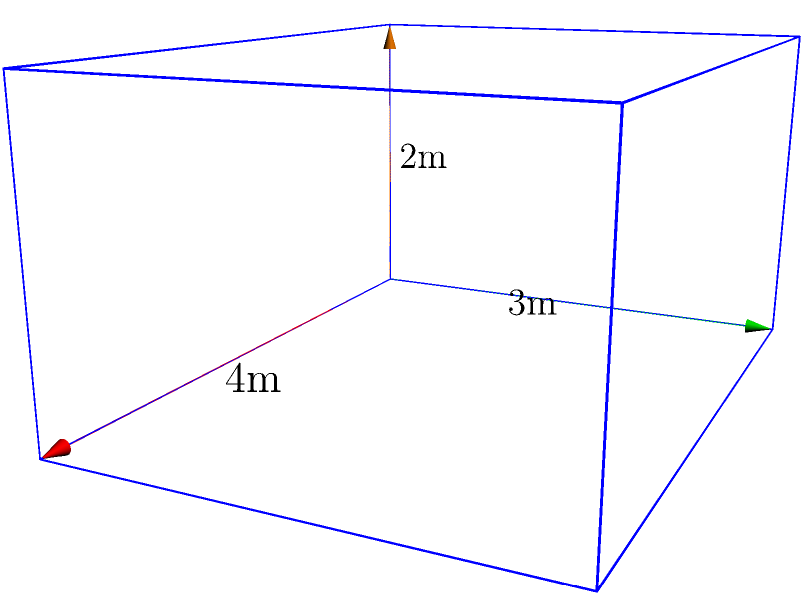A temporary health clinic structure for a tribal community outreach program is designed in the shape of a cuboid. The structure's dimensions are 4 meters in length, 3 meters in width, and 2 meters in height. If the clinic needs to maintain a minimum air volume of 20 cubic meters for proper ventilation, does this structure meet the requirement? If not, by how many cubic meters does it fall short? To solve this problem, we need to follow these steps:

1. Calculate the volume of the cuboid-shaped clinic:
   Volume = length × width × height
   $$V = 4 \text{ m} \times 3 \text{ m} \times 2 \text{ m} = 24 \text{ m}^3$$

2. Compare the calculated volume with the required minimum volume:
   Required minimum volume = 20 m³
   Calculated volume = 24 m³

3. Determine if the requirement is met:
   24 m³ > 20 m³, so the requirement is met.

4. Calculate the excess volume:
   Excess volume = Calculated volume - Required minimum volume
   $$24 \text{ m}^3 - 20 \text{ m}^3 = 4 \text{ m}^3$$

Therefore, the structure not only meets the minimum air volume requirement but exceeds it by 4 cubic meters.
Answer: Yes; exceeds by 4 m³ 